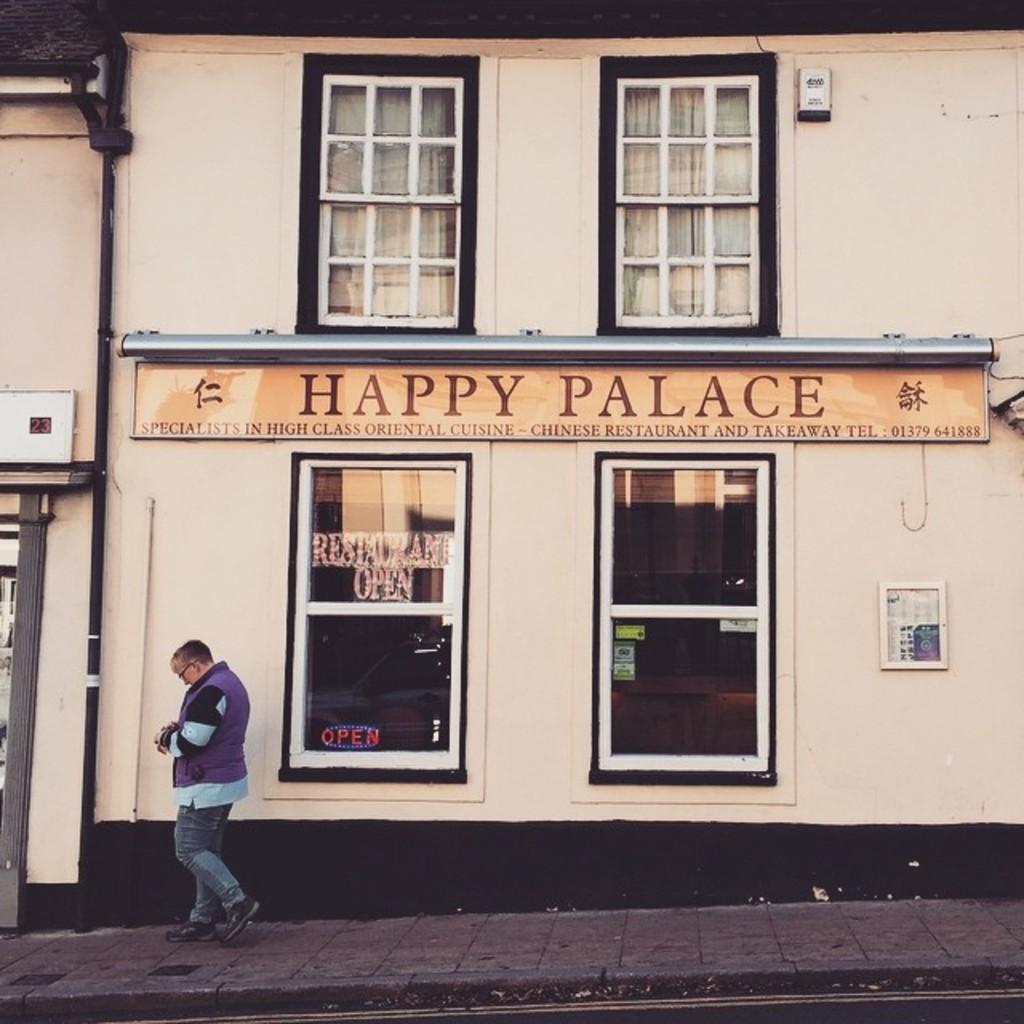Describe this image in one or two sentences. In this picture we can see a person walking on a footpath and in the background we can see windows, curtains, name board, pipe, wall. 